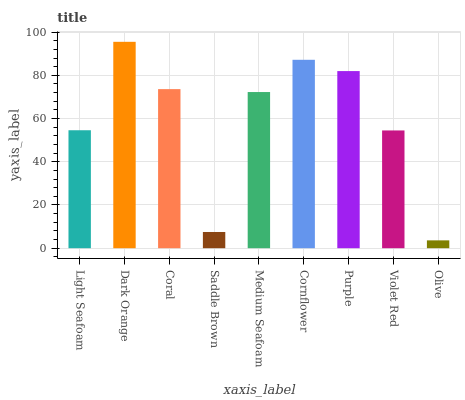Is Olive the minimum?
Answer yes or no. Yes. Is Dark Orange the maximum?
Answer yes or no. Yes. Is Coral the minimum?
Answer yes or no. No. Is Coral the maximum?
Answer yes or no. No. Is Dark Orange greater than Coral?
Answer yes or no. Yes. Is Coral less than Dark Orange?
Answer yes or no. Yes. Is Coral greater than Dark Orange?
Answer yes or no. No. Is Dark Orange less than Coral?
Answer yes or no. No. Is Medium Seafoam the high median?
Answer yes or no. Yes. Is Medium Seafoam the low median?
Answer yes or no. Yes. Is Saddle Brown the high median?
Answer yes or no. No. Is Cornflower the low median?
Answer yes or no. No. 